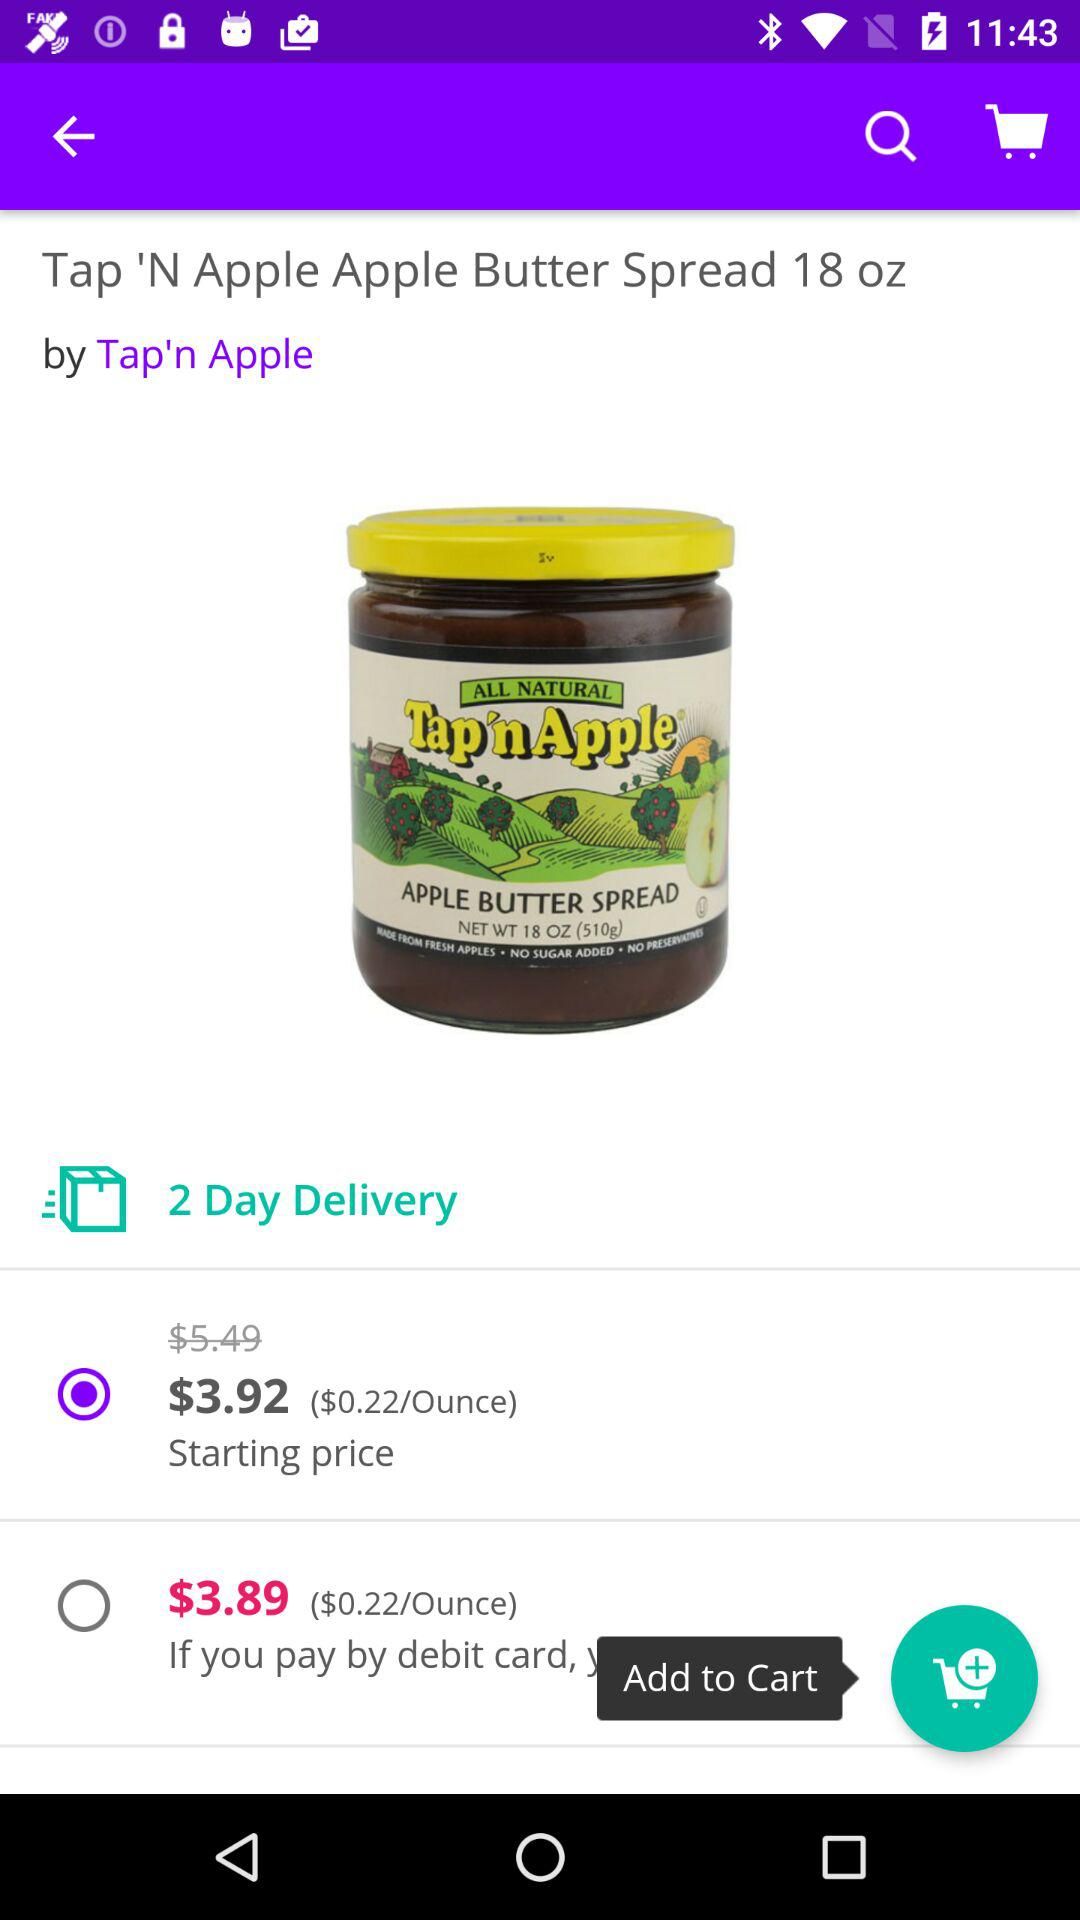What's the number of days within which delivery will be done? The delivery will be done within 2 days. 